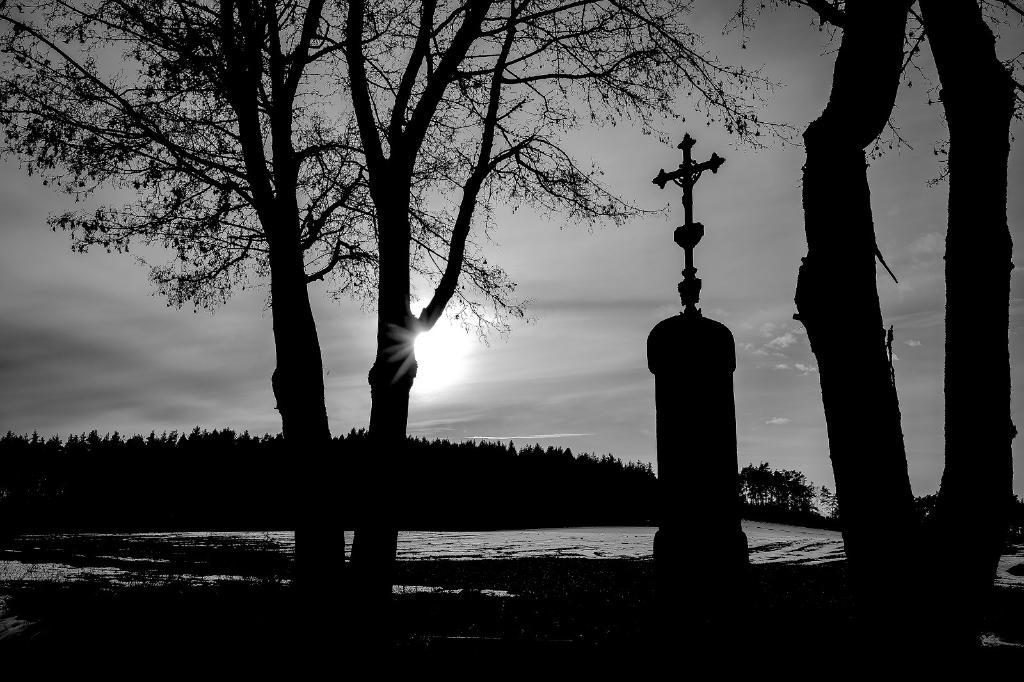What is the color scheme of the image? The image is black and white. What type of natural elements can be seen in the image? There are trees and water visible in the image. What symbol is present in the image? There is a cross symbol in the image. What part of the natural environment is visible in the background of the image? The sky is visible in the background of the image. How many teeth can be seen in the image? There are no teeth visible in the image. What type of net is being used to catch fish in the image? There is no net present in the image, and no fishing activity is depicted. 